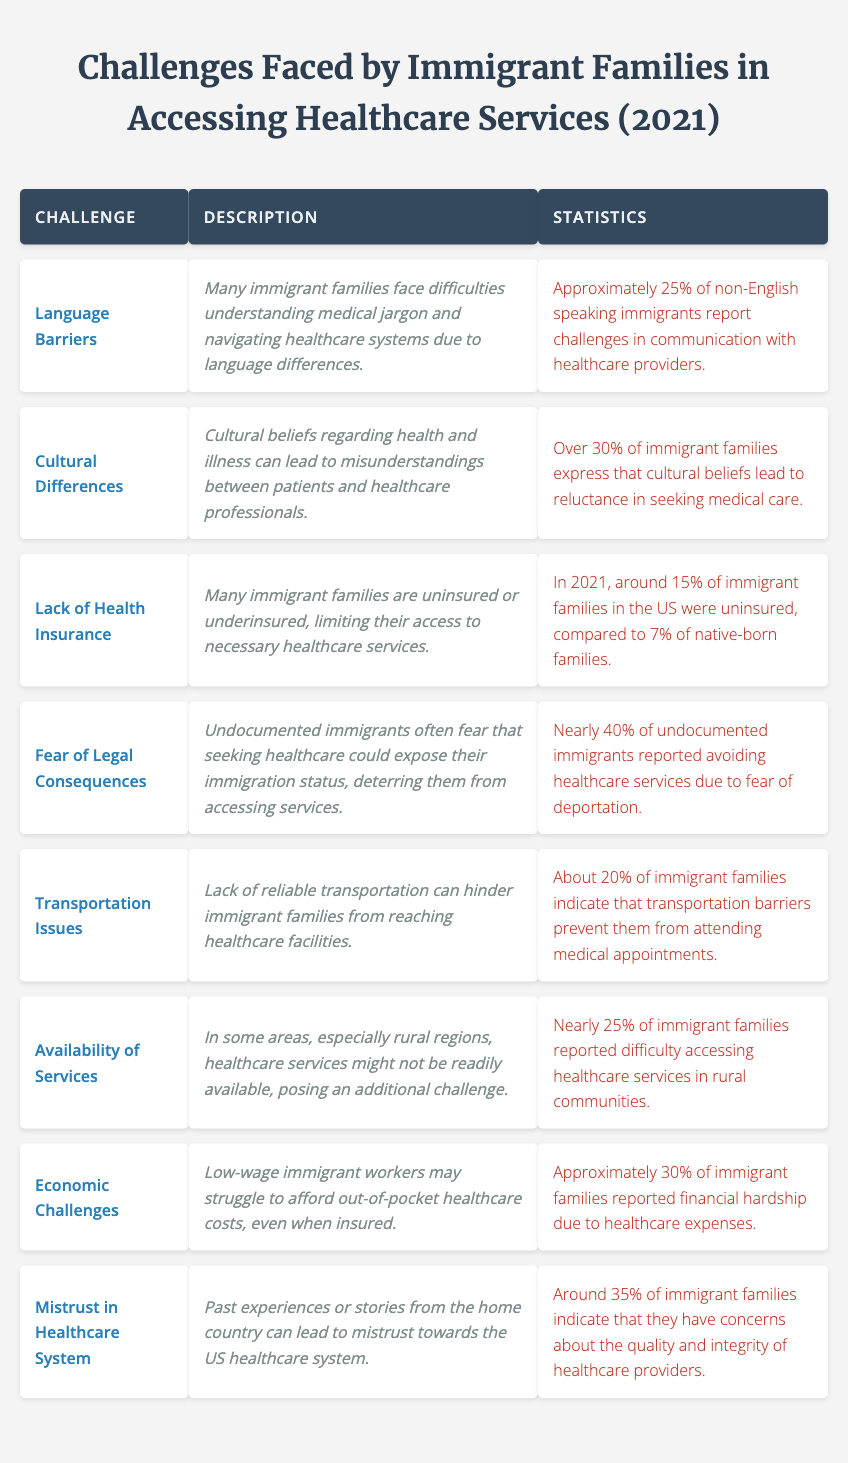What is the challenge associated with the lack of reliable transportation? The table identifies "Transportation Issues" as a challenge where lack of reliable transportation can hinder immigrant families from reaching healthcare facilities.
Answer: Transportation Issues What percentage of immigrant families reported avoiding healthcare services due to fear of deportation? From the table, it states that nearly 40% of undocumented immigrants reported avoiding healthcare services due to fear of deportation.
Answer: 40% Which challenge has the highest percentage of immigrant families expressing difficulties with its associated issue? "Cultural Differences" has over 30% of immigrant families expressing reluctance in seeking medical care due to cultural beliefs, making it the challenge with the highest percentage in the table.
Answer: Cultural Differences How many challenges mentioned in the table have over 30% of immigrant families reporting issues? There are three challenges: "Cultural Differences" (over 30%), "Mistrust in Healthcare System" (around 35%), and "Economic Challenges" (approximately 30%), totaling three challenges with over 30%.
Answer: 3 What is the difference in the percentage of uninsured immigrant families compared to native-born families? These figures indicate that 15% of immigrant families were uninsured while 7% of native-born families were uninsured, leading to a difference of 8%.
Answer: 8% 